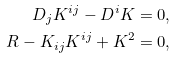Convert formula to latex. <formula><loc_0><loc_0><loc_500><loc_500>D _ { j } K ^ { i j } - D ^ { i } K = 0 , \\ R - K _ { i j } K ^ { i j } + K ^ { 2 } = 0 ,</formula> 